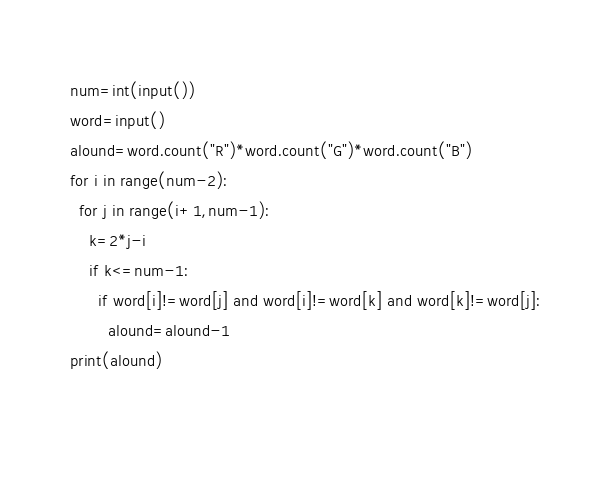Convert code to text. <code><loc_0><loc_0><loc_500><loc_500><_Python_>num=int(input())
word=input()
alound=word.count("R")*word.count("G")*word.count("B")
for i in range(num-2):
  for j in range(i+1,num-1):
    k=2*j-i
    if k<=num-1:
      if word[i]!=word[j] and word[i]!=word[k] and word[k]!=word[j]:
        alound=alound-1
print(alound)
  
      </code> 